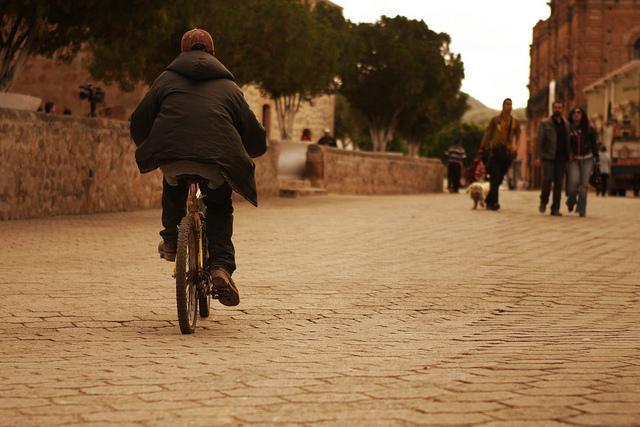How many bikes are there?
Give a very brief answer. 1. How many people are visible?
Give a very brief answer. 4. How many elephants are here?
Give a very brief answer. 0. 